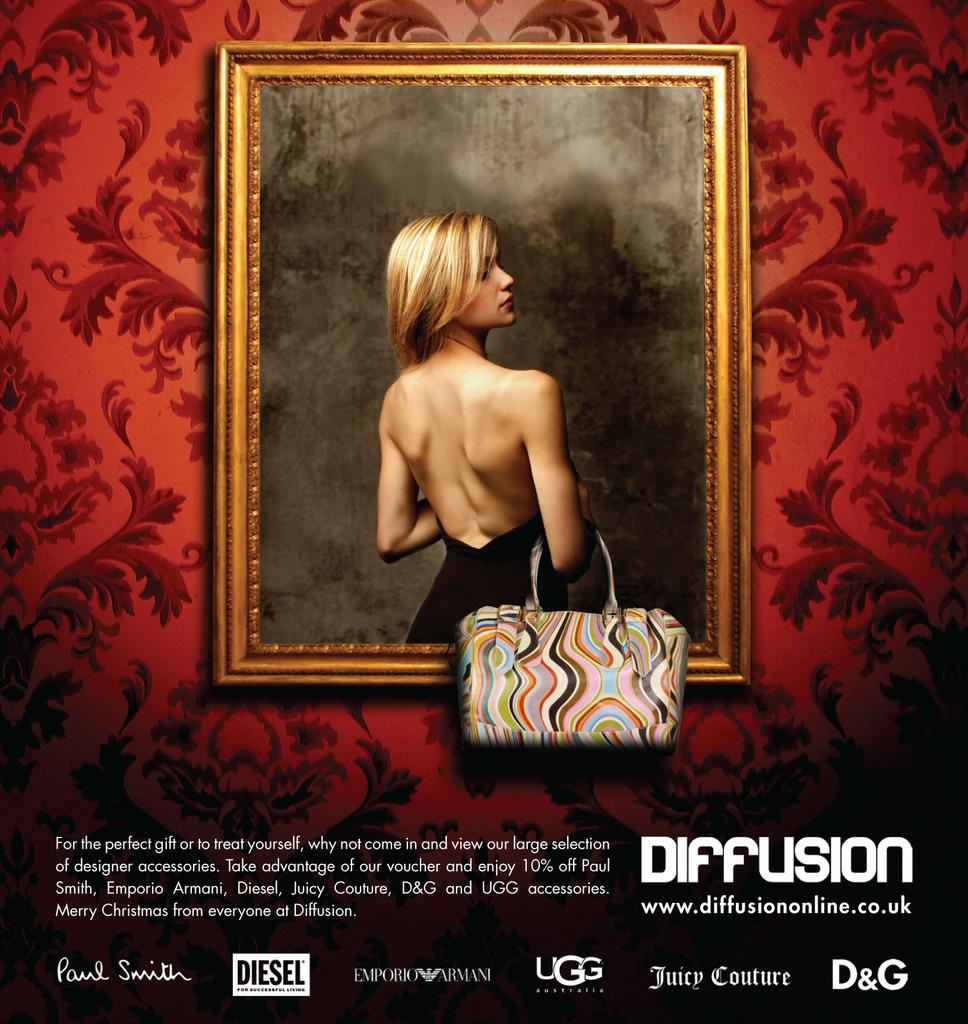What is present in the image that has a defined structure or border? There is a frame in the image. Who or what can be seen inside the frame? There is a woman in the image. What is the woman holding in the image? The woman is holding a handbag. What type of quarter is being discussed in the meeting depicted in the image? There is no meeting or discussion of a quarter present in the image. How many cows can be seen grazing in the background of the image? There are no cows present in the image. 